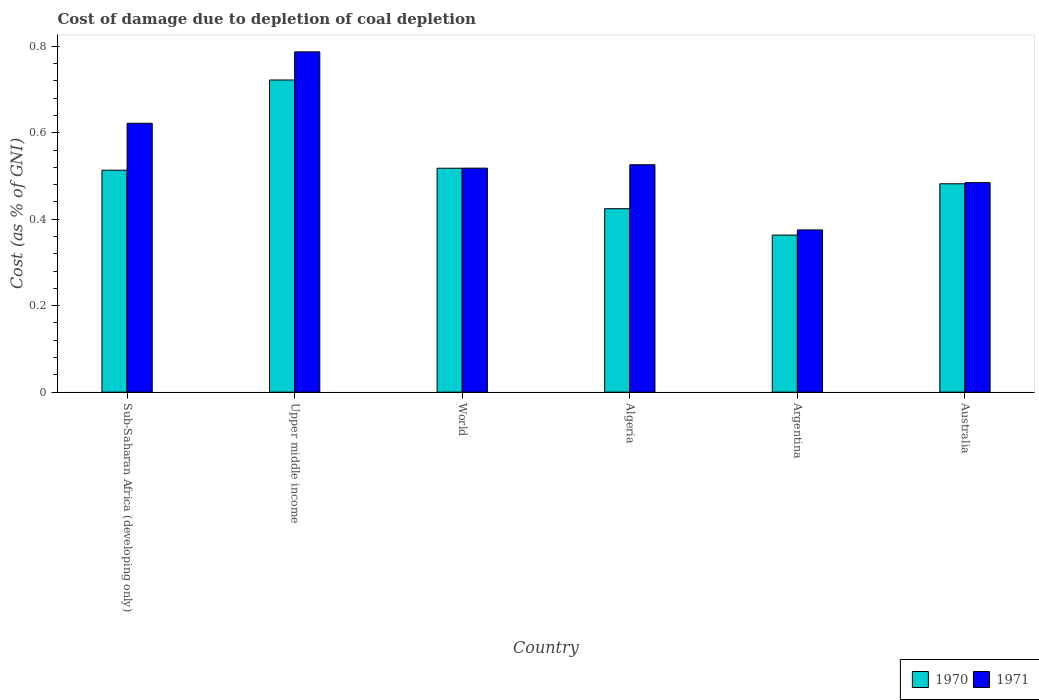Are the number of bars on each tick of the X-axis equal?
Give a very brief answer. Yes. How many bars are there on the 2nd tick from the left?
Make the answer very short. 2. How many bars are there on the 3rd tick from the right?
Give a very brief answer. 2. What is the label of the 4th group of bars from the left?
Make the answer very short. Algeria. In how many cases, is the number of bars for a given country not equal to the number of legend labels?
Your answer should be very brief. 0. What is the cost of damage caused due to coal depletion in 1971 in Australia?
Offer a terse response. 0.48. Across all countries, what is the maximum cost of damage caused due to coal depletion in 1971?
Make the answer very short. 0.79. Across all countries, what is the minimum cost of damage caused due to coal depletion in 1970?
Provide a short and direct response. 0.36. In which country was the cost of damage caused due to coal depletion in 1971 maximum?
Your answer should be very brief. Upper middle income. What is the total cost of damage caused due to coal depletion in 1971 in the graph?
Your answer should be very brief. 3.31. What is the difference between the cost of damage caused due to coal depletion in 1970 in Argentina and that in Sub-Saharan Africa (developing only)?
Ensure brevity in your answer.  -0.15. What is the difference between the cost of damage caused due to coal depletion in 1971 in Upper middle income and the cost of damage caused due to coal depletion in 1970 in Argentina?
Ensure brevity in your answer.  0.42. What is the average cost of damage caused due to coal depletion in 1971 per country?
Your response must be concise. 0.55. What is the difference between the cost of damage caused due to coal depletion of/in 1971 and cost of damage caused due to coal depletion of/in 1970 in Australia?
Offer a very short reply. 0. What is the ratio of the cost of damage caused due to coal depletion in 1970 in Upper middle income to that in World?
Give a very brief answer. 1.39. Is the difference between the cost of damage caused due to coal depletion in 1971 in Algeria and Argentina greater than the difference between the cost of damage caused due to coal depletion in 1970 in Algeria and Argentina?
Offer a terse response. Yes. What is the difference between the highest and the second highest cost of damage caused due to coal depletion in 1970?
Give a very brief answer. 0.2. What is the difference between the highest and the lowest cost of damage caused due to coal depletion in 1970?
Your answer should be compact. 0.36. Is the sum of the cost of damage caused due to coal depletion in 1971 in Sub-Saharan Africa (developing only) and World greater than the maximum cost of damage caused due to coal depletion in 1970 across all countries?
Provide a short and direct response. Yes. How many bars are there?
Offer a very short reply. 12. Are all the bars in the graph horizontal?
Offer a very short reply. No. How many countries are there in the graph?
Give a very brief answer. 6. What is the difference between two consecutive major ticks on the Y-axis?
Your response must be concise. 0.2. Are the values on the major ticks of Y-axis written in scientific E-notation?
Your answer should be compact. No. Does the graph contain grids?
Provide a succinct answer. No. Where does the legend appear in the graph?
Your response must be concise. Bottom right. How are the legend labels stacked?
Offer a terse response. Horizontal. What is the title of the graph?
Your answer should be compact. Cost of damage due to depletion of coal depletion. What is the label or title of the X-axis?
Your answer should be compact. Country. What is the label or title of the Y-axis?
Your answer should be very brief. Cost (as % of GNI). What is the Cost (as % of GNI) of 1970 in Sub-Saharan Africa (developing only)?
Your answer should be very brief. 0.51. What is the Cost (as % of GNI) in 1971 in Sub-Saharan Africa (developing only)?
Your answer should be very brief. 0.62. What is the Cost (as % of GNI) of 1970 in Upper middle income?
Keep it short and to the point. 0.72. What is the Cost (as % of GNI) in 1971 in Upper middle income?
Offer a very short reply. 0.79. What is the Cost (as % of GNI) in 1970 in World?
Provide a succinct answer. 0.52. What is the Cost (as % of GNI) in 1971 in World?
Make the answer very short. 0.52. What is the Cost (as % of GNI) of 1970 in Algeria?
Your response must be concise. 0.42. What is the Cost (as % of GNI) in 1971 in Algeria?
Keep it short and to the point. 0.53. What is the Cost (as % of GNI) in 1970 in Argentina?
Offer a very short reply. 0.36. What is the Cost (as % of GNI) in 1971 in Argentina?
Your answer should be very brief. 0.38. What is the Cost (as % of GNI) in 1970 in Australia?
Offer a very short reply. 0.48. What is the Cost (as % of GNI) in 1971 in Australia?
Offer a terse response. 0.48. Across all countries, what is the maximum Cost (as % of GNI) of 1970?
Provide a succinct answer. 0.72. Across all countries, what is the maximum Cost (as % of GNI) of 1971?
Offer a very short reply. 0.79. Across all countries, what is the minimum Cost (as % of GNI) in 1970?
Offer a terse response. 0.36. Across all countries, what is the minimum Cost (as % of GNI) of 1971?
Ensure brevity in your answer.  0.38. What is the total Cost (as % of GNI) of 1970 in the graph?
Make the answer very short. 3.02. What is the total Cost (as % of GNI) in 1971 in the graph?
Offer a terse response. 3.31. What is the difference between the Cost (as % of GNI) of 1970 in Sub-Saharan Africa (developing only) and that in Upper middle income?
Offer a very short reply. -0.21. What is the difference between the Cost (as % of GNI) of 1971 in Sub-Saharan Africa (developing only) and that in Upper middle income?
Make the answer very short. -0.17. What is the difference between the Cost (as % of GNI) of 1970 in Sub-Saharan Africa (developing only) and that in World?
Your answer should be compact. -0. What is the difference between the Cost (as % of GNI) in 1971 in Sub-Saharan Africa (developing only) and that in World?
Your answer should be very brief. 0.1. What is the difference between the Cost (as % of GNI) in 1970 in Sub-Saharan Africa (developing only) and that in Algeria?
Your answer should be very brief. 0.09. What is the difference between the Cost (as % of GNI) of 1971 in Sub-Saharan Africa (developing only) and that in Algeria?
Your response must be concise. 0.1. What is the difference between the Cost (as % of GNI) of 1970 in Sub-Saharan Africa (developing only) and that in Argentina?
Provide a short and direct response. 0.15. What is the difference between the Cost (as % of GNI) of 1971 in Sub-Saharan Africa (developing only) and that in Argentina?
Offer a terse response. 0.25. What is the difference between the Cost (as % of GNI) of 1970 in Sub-Saharan Africa (developing only) and that in Australia?
Keep it short and to the point. 0.03. What is the difference between the Cost (as % of GNI) of 1971 in Sub-Saharan Africa (developing only) and that in Australia?
Keep it short and to the point. 0.14. What is the difference between the Cost (as % of GNI) of 1970 in Upper middle income and that in World?
Keep it short and to the point. 0.2. What is the difference between the Cost (as % of GNI) in 1971 in Upper middle income and that in World?
Ensure brevity in your answer.  0.27. What is the difference between the Cost (as % of GNI) in 1970 in Upper middle income and that in Algeria?
Your answer should be compact. 0.3. What is the difference between the Cost (as % of GNI) of 1971 in Upper middle income and that in Algeria?
Give a very brief answer. 0.26. What is the difference between the Cost (as % of GNI) of 1970 in Upper middle income and that in Argentina?
Provide a succinct answer. 0.36. What is the difference between the Cost (as % of GNI) in 1971 in Upper middle income and that in Argentina?
Your response must be concise. 0.41. What is the difference between the Cost (as % of GNI) of 1970 in Upper middle income and that in Australia?
Provide a succinct answer. 0.24. What is the difference between the Cost (as % of GNI) in 1971 in Upper middle income and that in Australia?
Provide a short and direct response. 0.3. What is the difference between the Cost (as % of GNI) in 1970 in World and that in Algeria?
Ensure brevity in your answer.  0.09. What is the difference between the Cost (as % of GNI) of 1971 in World and that in Algeria?
Provide a short and direct response. -0.01. What is the difference between the Cost (as % of GNI) of 1970 in World and that in Argentina?
Provide a short and direct response. 0.15. What is the difference between the Cost (as % of GNI) of 1971 in World and that in Argentina?
Ensure brevity in your answer.  0.14. What is the difference between the Cost (as % of GNI) of 1970 in World and that in Australia?
Your answer should be very brief. 0.04. What is the difference between the Cost (as % of GNI) of 1971 in World and that in Australia?
Ensure brevity in your answer.  0.03. What is the difference between the Cost (as % of GNI) of 1970 in Algeria and that in Argentina?
Keep it short and to the point. 0.06. What is the difference between the Cost (as % of GNI) of 1971 in Algeria and that in Argentina?
Offer a terse response. 0.15. What is the difference between the Cost (as % of GNI) of 1970 in Algeria and that in Australia?
Provide a short and direct response. -0.06. What is the difference between the Cost (as % of GNI) in 1971 in Algeria and that in Australia?
Keep it short and to the point. 0.04. What is the difference between the Cost (as % of GNI) in 1970 in Argentina and that in Australia?
Provide a succinct answer. -0.12. What is the difference between the Cost (as % of GNI) of 1971 in Argentina and that in Australia?
Make the answer very short. -0.11. What is the difference between the Cost (as % of GNI) of 1970 in Sub-Saharan Africa (developing only) and the Cost (as % of GNI) of 1971 in Upper middle income?
Your response must be concise. -0.27. What is the difference between the Cost (as % of GNI) in 1970 in Sub-Saharan Africa (developing only) and the Cost (as % of GNI) in 1971 in World?
Give a very brief answer. -0. What is the difference between the Cost (as % of GNI) of 1970 in Sub-Saharan Africa (developing only) and the Cost (as % of GNI) of 1971 in Algeria?
Make the answer very short. -0.01. What is the difference between the Cost (as % of GNI) in 1970 in Sub-Saharan Africa (developing only) and the Cost (as % of GNI) in 1971 in Argentina?
Your answer should be compact. 0.14. What is the difference between the Cost (as % of GNI) of 1970 in Sub-Saharan Africa (developing only) and the Cost (as % of GNI) of 1971 in Australia?
Keep it short and to the point. 0.03. What is the difference between the Cost (as % of GNI) of 1970 in Upper middle income and the Cost (as % of GNI) of 1971 in World?
Provide a short and direct response. 0.2. What is the difference between the Cost (as % of GNI) in 1970 in Upper middle income and the Cost (as % of GNI) in 1971 in Algeria?
Give a very brief answer. 0.2. What is the difference between the Cost (as % of GNI) in 1970 in Upper middle income and the Cost (as % of GNI) in 1971 in Argentina?
Give a very brief answer. 0.35. What is the difference between the Cost (as % of GNI) of 1970 in Upper middle income and the Cost (as % of GNI) of 1971 in Australia?
Your answer should be very brief. 0.24. What is the difference between the Cost (as % of GNI) of 1970 in World and the Cost (as % of GNI) of 1971 in Algeria?
Provide a short and direct response. -0.01. What is the difference between the Cost (as % of GNI) of 1970 in World and the Cost (as % of GNI) of 1971 in Argentina?
Keep it short and to the point. 0.14. What is the difference between the Cost (as % of GNI) in 1970 in World and the Cost (as % of GNI) in 1971 in Australia?
Your answer should be very brief. 0.03. What is the difference between the Cost (as % of GNI) in 1970 in Algeria and the Cost (as % of GNI) in 1971 in Argentina?
Give a very brief answer. 0.05. What is the difference between the Cost (as % of GNI) in 1970 in Algeria and the Cost (as % of GNI) in 1971 in Australia?
Your answer should be very brief. -0.06. What is the difference between the Cost (as % of GNI) of 1970 in Argentina and the Cost (as % of GNI) of 1971 in Australia?
Give a very brief answer. -0.12. What is the average Cost (as % of GNI) of 1970 per country?
Ensure brevity in your answer.  0.5. What is the average Cost (as % of GNI) of 1971 per country?
Give a very brief answer. 0.55. What is the difference between the Cost (as % of GNI) in 1970 and Cost (as % of GNI) in 1971 in Sub-Saharan Africa (developing only)?
Keep it short and to the point. -0.11. What is the difference between the Cost (as % of GNI) in 1970 and Cost (as % of GNI) in 1971 in Upper middle income?
Provide a succinct answer. -0.07. What is the difference between the Cost (as % of GNI) of 1970 and Cost (as % of GNI) of 1971 in World?
Your response must be concise. -0. What is the difference between the Cost (as % of GNI) in 1970 and Cost (as % of GNI) in 1971 in Algeria?
Make the answer very short. -0.1. What is the difference between the Cost (as % of GNI) in 1970 and Cost (as % of GNI) in 1971 in Argentina?
Provide a short and direct response. -0.01. What is the difference between the Cost (as % of GNI) in 1970 and Cost (as % of GNI) in 1971 in Australia?
Make the answer very short. -0. What is the ratio of the Cost (as % of GNI) in 1970 in Sub-Saharan Africa (developing only) to that in Upper middle income?
Make the answer very short. 0.71. What is the ratio of the Cost (as % of GNI) in 1971 in Sub-Saharan Africa (developing only) to that in Upper middle income?
Provide a short and direct response. 0.79. What is the ratio of the Cost (as % of GNI) in 1971 in Sub-Saharan Africa (developing only) to that in World?
Provide a short and direct response. 1.2. What is the ratio of the Cost (as % of GNI) in 1970 in Sub-Saharan Africa (developing only) to that in Algeria?
Offer a terse response. 1.21. What is the ratio of the Cost (as % of GNI) in 1971 in Sub-Saharan Africa (developing only) to that in Algeria?
Offer a very short reply. 1.18. What is the ratio of the Cost (as % of GNI) in 1970 in Sub-Saharan Africa (developing only) to that in Argentina?
Keep it short and to the point. 1.41. What is the ratio of the Cost (as % of GNI) of 1971 in Sub-Saharan Africa (developing only) to that in Argentina?
Keep it short and to the point. 1.66. What is the ratio of the Cost (as % of GNI) in 1970 in Sub-Saharan Africa (developing only) to that in Australia?
Provide a short and direct response. 1.07. What is the ratio of the Cost (as % of GNI) in 1971 in Sub-Saharan Africa (developing only) to that in Australia?
Offer a terse response. 1.28. What is the ratio of the Cost (as % of GNI) of 1970 in Upper middle income to that in World?
Give a very brief answer. 1.39. What is the ratio of the Cost (as % of GNI) of 1971 in Upper middle income to that in World?
Your response must be concise. 1.52. What is the ratio of the Cost (as % of GNI) of 1970 in Upper middle income to that in Algeria?
Offer a terse response. 1.7. What is the ratio of the Cost (as % of GNI) of 1971 in Upper middle income to that in Algeria?
Your answer should be compact. 1.5. What is the ratio of the Cost (as % of GNI) of 1970 in Upper middle income to that in Argentina?
Provide a short and direct response. 1.99. What is the ratio of the Cost (as % of GNI) of 1971 in Upper middle income to that in Argentina?
Provide a succinct answer. 2.1. What is the ratio of the Cost (as % of GNI) of 1970 in Upper middle income to that in Australia?
Provide a succinct answer. 1.5. What is the ratio of the Cost (as % of GNI) of 1971 in Upper middle income to that in Australia?
Offer a very short reply. 1.62. What is the ratio of the Cost (as % of GNI) in 1970 in World to that in Algeria?
Offer a terse response. 1.22. What is the ratio of the Cost (as % of GNI) of 1971 in World to that in Algeria?
Offer a very short reply. 0.99. What is the ratio of the Cost (as % of GNI) of 1970 in World to that in Argentina?
Provide a short and direct response. 1.43. What is the ratio of the Cost (as % of GNI) in 1971 in World to that in Argentina?
Offer a very short reply. 1.38. What is the ratio of the Cost (as % of GNI) of 1970 in World to that in Australia?
Ensure brevity in your answer.  1.07. What is the ratio of the Cost (as % of GNI) of 1971 in World to that in Australia?
Give a very brief answer. 1.07. What is the ratio of the Cost (as % of GNI) of 1970 in Algeria to that in Argentina?
Your response must be concise. 1.17. What is the ratio of the Cost (as % of GNI) in 1971 in Algeria to that in Argentina?
Provide a succinct answer. 1.4. What is the ratio of the Cost (as % of GNI) in 1970 in Algeria to that in Australia?
Offer a very short reply. 0.88. What is the ratio of the Cost (as % of GNI) of 1971 in Algeria to that in Australia?
Your answer should be compact. 1.09. What is the ratio of the Cost (as % of GNI) in 1970 in Argentina to that in Australia?
Provide a short and direct response. 0.75. What is the ratio of the Cost (as % of GNI) in 1971 in Argentina to that in Australia?
Your answer should be compact. 0.77. What is the difference between the highest and the second highest Cost (as % of GNI) in 1970?
Provide a succinct answer. 0.2. What is the difference between the highest and the second highest Cost (as % of GNI) of 1971?
Offer a terse response. 0.17. What is the difference between the highest and the lowest Cost (as % of GNI) in 1970?
Your response must be concise. 0.36. What is the difference between the highest and the lowest Cost (as % of GNI) in 1971?
Offer a very short reply. 0.41. 